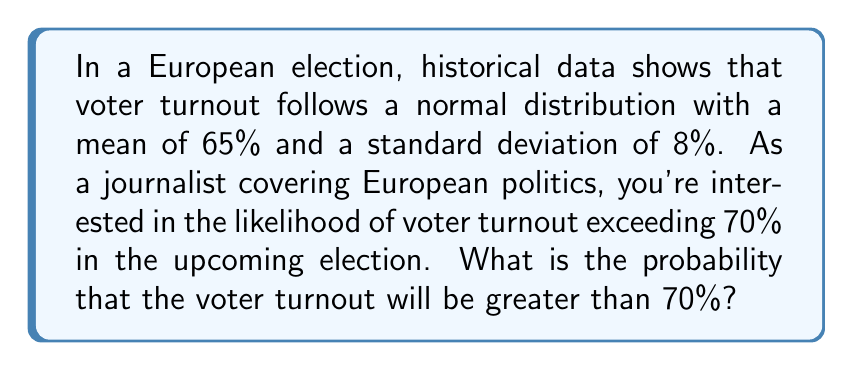Solve this math problem. To solve this problem, we need to use the properties of the normal distribution and the concept of z-scores.

1. First, we identify the given information:
   - Mean ($\mu$) = 65%
   - Standard deviation ($\sigma$) = 8%
   - We want to find P(X > 70%), where X is the voter turnout

2. Calculate the z-score for 70%:
   $$z = \frac{x - \mu}{\sigma} = \frac{70 - 65}{8} = \frac{5}{8} = 0.625$$

3. Now, we need to find the probability of Z > 0.625 in the standard normal distribution.

4. Using a standard normal distribution table or calculator, we can find:
   P(Z > 0.625) = 1 - P(Z < 0.625) = 1 - 0.7340 = 0.2660

5. Therefore, the probability of voter turnout exceeding 70% is approximately 0.2660 or 26.60%.

This result suggests that while exceeding 70% turnout is not the most likely outcome, it's still a significant possibility, occurring in about one out of every four elections under these conditions.
Answer: The probability that voter turnout will exceed 70% is approximately 0.2660 or 26.60%. 